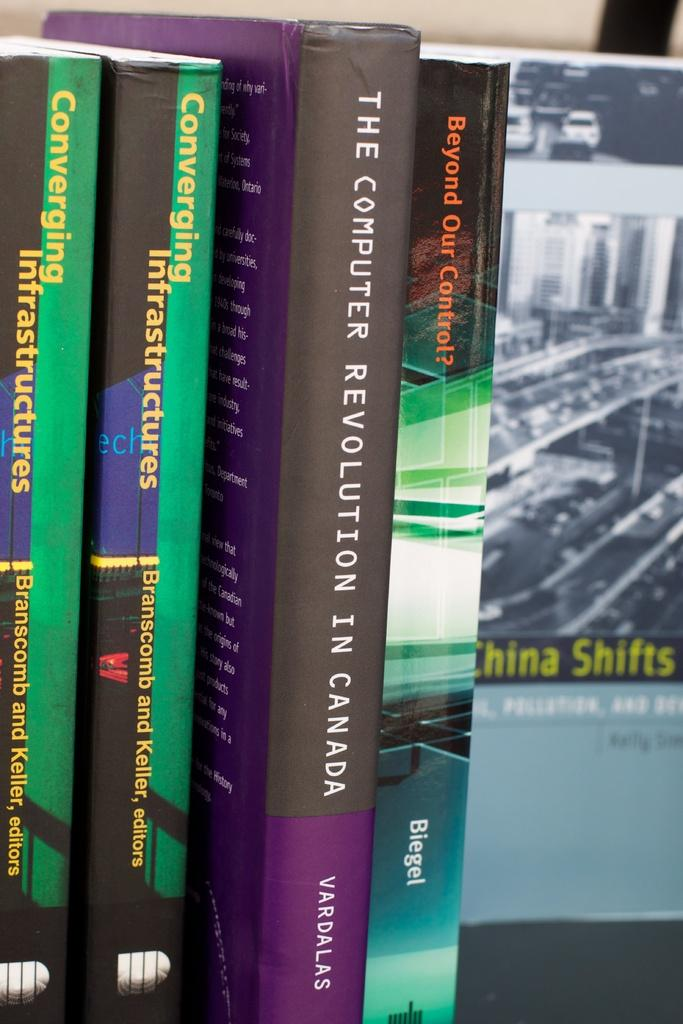<image>
Describe the image concisely. Several books sit on a shelf including The computer revolution in Canada. 